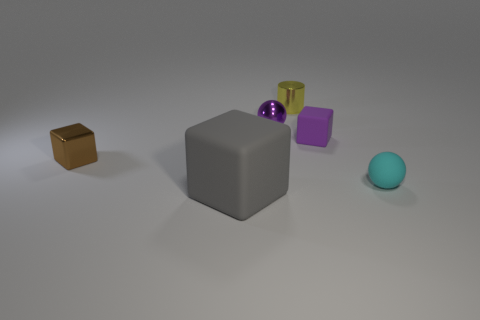Subtract all metal blocks. How many blocks are left? 2 Subtract all purple blocks. How many blocks are left? 2 Add 1 brown shiny blocks. How many objects exist? 7 Subtract all balls. How many objects are left? 4 Subtract 2 cubes. How many cubes are left? 1 Add 6 tiny shiny cubes. How many tiny shiny cubes are left? 7 Add 2 small purple balls. How many small purple balls exist? 3 Subtract 0 green balls. How many objects are left? 6 Subtract all green cubes. Subtract all red balls. How many cubes are left? 3 Subtract all tiny red metallic balls. Subtract all small brown things. How many objects are left? 5 